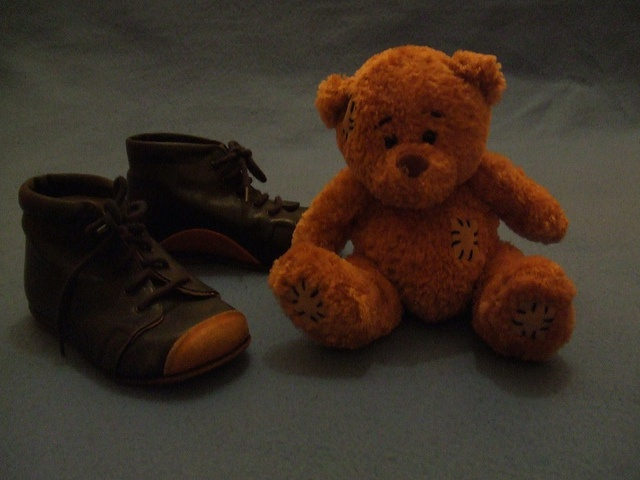Describe the objects in this image and their specific colors. I can see a teddy bear in black, maroon, and brown tones in this image. 